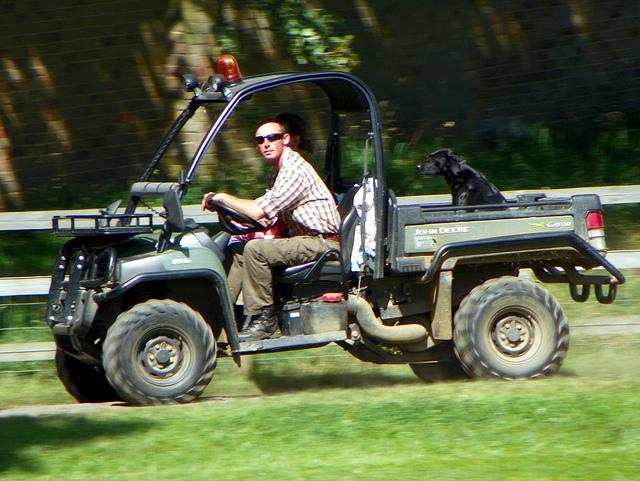Why is the dog in the back? riding 